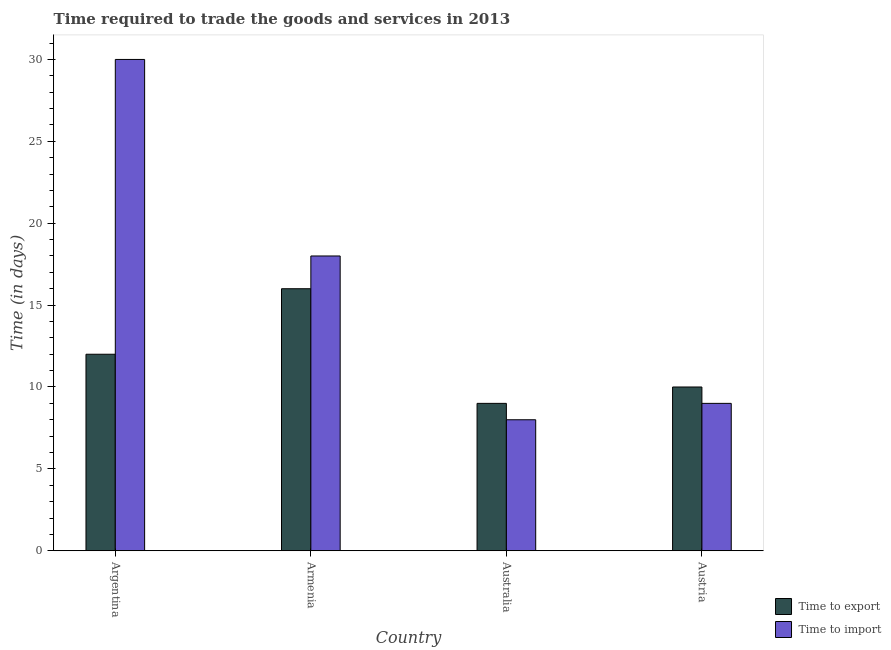How many groups of bars are there?
Your answer should be very brief. 4. How many bars are there on the 3rd tick from the right?
Your answer should be compact. 2. In how many cases, is the number of bars for a given country not equal to the number of legend labels?
Keep it short and to the point. 0. Across all countries, what is the minimum time to import?
Provide a succinct answer. 8. In which country was the time to import minimum?
Your answer should be compact. Australia. What is the total time to export in the graph?
Make the answer very short. 47. What is the average time to import per country?
Offer a very short reply. 16.25. In how many countries, is the time to import greater than 4 days?
Offer a terse response. 4. Is the time to import in Armenia less than that in Austria?
Your answer should be compact. No. Is the difference between the time to export in Armenia and Austria greater than the difference between the time to import in Armenia and Austria?
Keep it short and to the point. No. What is the difference between the highest and the lowest time to export?
Offer a terse response. 7. Is the sum of the time to export in Argentina and Austria greater than the maximum time to import across all countries?
Make the answer very short. No. What does the 1st bar from the left in Armenia represents?
Offer a terse response. Time to export. What does the 1st bar from the right in Australia represents?
Your response must be concise. Time to import. How many bars are there?
Offer a terse response. 8. Are all the bars in the graph horizontal?
Offer a terse response. No. Does the graph contain grids?
Your response must be concise. No. How many legend labels are there?
Offer a very short reply. 2. What is the title of the graph?
Your response must be concise. Time required to trade the goods and services in 2013. What is the label or title of the X-axis?
Provide a short and direct response. Country. What is the label or title of the Y-axis?
Your answer should be very brief. Time (in days). What is the Time (in days) in Time to export in Argentina?
Keep it short and to the point. 12. What is the Time (in days) in Time to export in Australia?
Your response must be concise. 9. What is the Time (in days) of Time to import in Australia?
Offer a terse response. 8. Across all countries, what is the maximum Time (in days) of Time to export?
Provide a succinct answer. 16. Across all countries, what is the minimum Time (in days) in Time to export?
Offer a very short reply. 9. What is the total Time (in days) of Time to export in the graph?
Your response must be concise. 47. What is the difference between the Time (in days) in Time to import in Argentina and that in Armenia?
Your response must be concise. 12. What is the difference between the Time (in days) in Time to import in Argentina and that in Australia?
Your response must be concise. 22. What is the difference between the Time (in days) in Time to import in Australia and that in Austria?
Provide a short and direct response. -1. What is the difference between the Time (in days) in Time to export in Argentina and the Time (in days) in Time to import in Armenia?
Your response must be concise. -6. What is the difference between the Time (in days) in Time to export in Argentina and the Time (in days) in Time to import in Australia?
Provide a short and direct response. 4. What is the difference between the Time (in days) in Time to export in Argentina and the Time (in days) in Time to import in Austria?
Offer a very short reply. 3. What is the difference between the Time (in days) in Time to export in Australia and the Time (in days) in Time to import in Austria?
Give a very brief answer. 0. What is the average Time (in days) in Time to export per country?
Offer a very short reply. 11.75. What is the average Time (in days) of Time to import per country?
Offer a very short reply. 16.25. What is the difference between the Time (in days) of Time to export and Time (in days) of Time to import in Armenia?
Provide a short and direct response. -2. What is the difference between the Time (in days) of Time to export and Time (in days) of Time to import in Australia?
Give a very brief answer. 1. What is the difference between the Time (in days) in Time to export and Time (in days) in Time to import in Austria?
Your answer should be compact. 1. What is the ratio of the Time (in days) in Time to export in Argentina to that in Armenia?
Make the answer very short. 0.75. What is the ratio of the Time (in days) in Time to export in Argentina to that in Australia?
Make the answer very short. 1.33. What is the ratio of the Time (in days) in Time to import in Argentina to that in Australia?
Keep it short and to the point. 3.75. What is the ratio of the Time (in days) of Time to export in Armenia to that in Australia?
Offer a very short reply. 1.78. What is the ratio of the Time (in days) of Time to import in Armenia to that in Australia?
Keep it short and to the point. 2.25. What is the ratio of the Time (in days) of Time to export in Australia to that in Austria?
Offer a terse response. 0.9. What is the ratio of the Time (in days) of Time to import in Australia to that in Austria?
Make the answer very short. 0.89. What is the difference between the highest and the second highest Time (in days) in Time to export?
Provide a short and direct response. 4. What is the difference between the highest and the second highest Time (in days) in Time to import?
Give a very brief answer. 12. What is the difference between the highest and the lowest Time (in days) in Time to import?
Your answer should be compact. 22. 